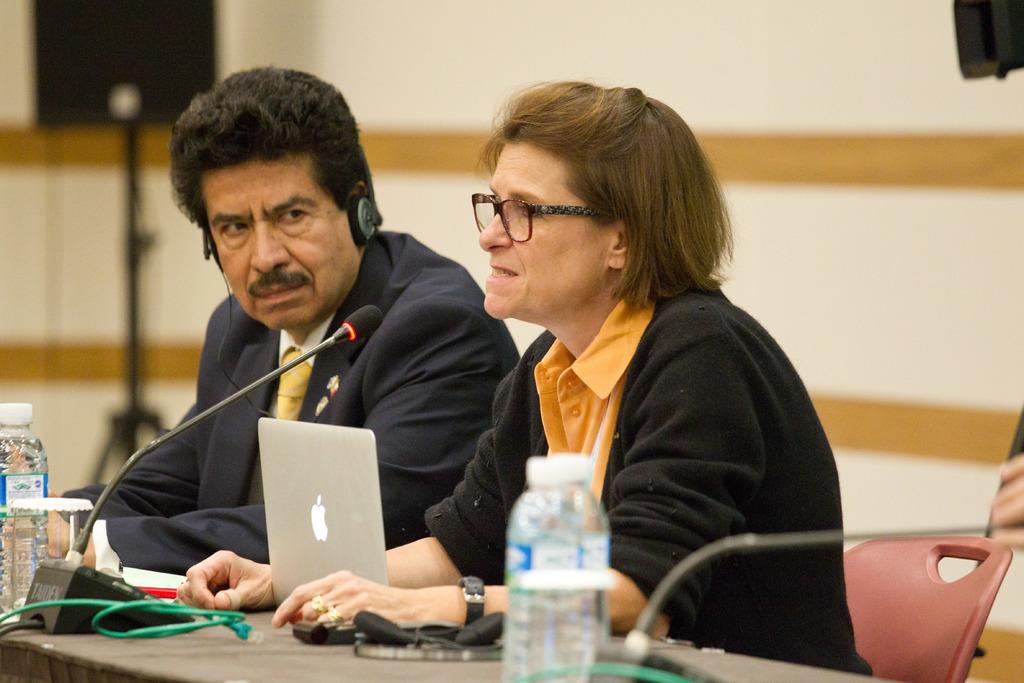How many people are in the image? There are two persons in the image. What are the persons doing in the image? The persons are sitting on chairs. What is in front of the chairs? There is a table in front of the chairs. What items can be seen on the table? There are bottles and laptops on the table. What is the woman doing in the image? A woman is speaking on a microphone. What type of prison can be seen in the background of the image? There is no prison present in the image; it features two people sitting on chairs with a table in front of them. How many umbrellas are being used by the persons in the image? There are no umbrellas present in the image. 